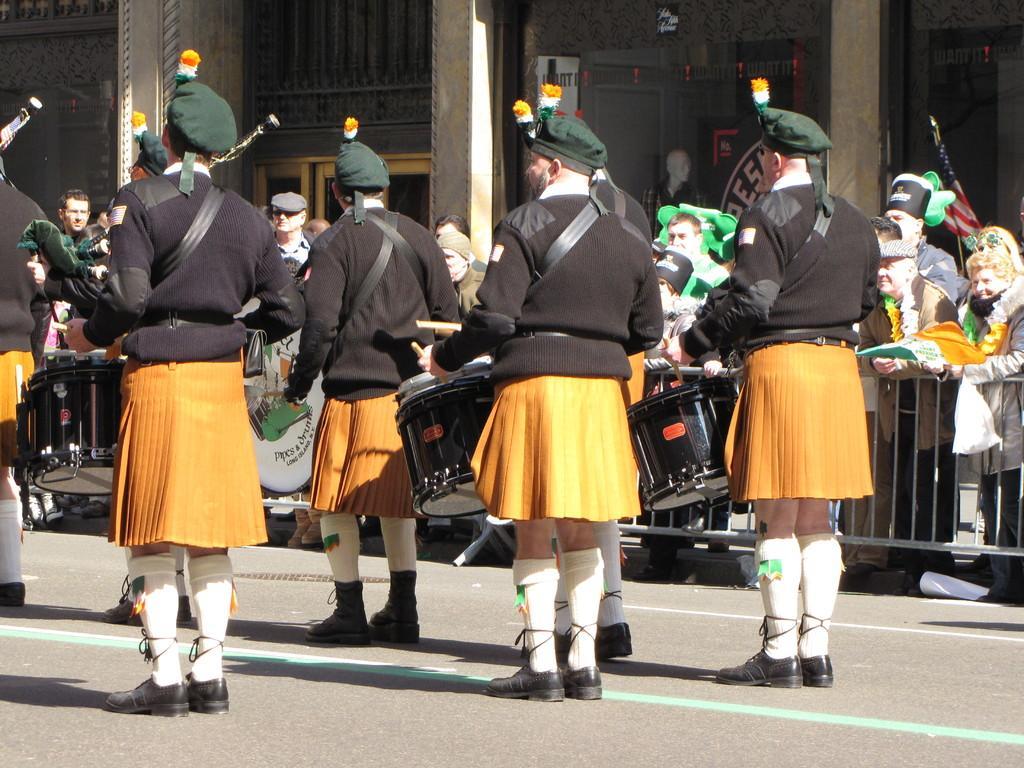Can you describe this image briefly? This picture describes about group of people, few people wore caps and few people playing drums, in the background we can see few metal rods, building and a flag. 